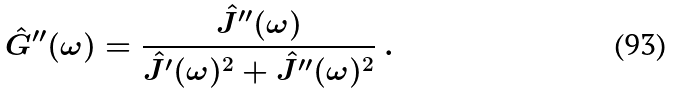Convert formula to latex. <formula><loc_0><loc_0><loc_500><loc_500>\hat { G } ^ { \prime \prime } ( \omega ) = \frac { \hat { J } ^ { \prime \prime } ( \omega ) } { \hat { J } ^ { \prime } ( \omega ) ^ { 2 } + \hat { J } ^ { \prime \prime } ( \omega ) ^ { 2 } } \ .</formula> 